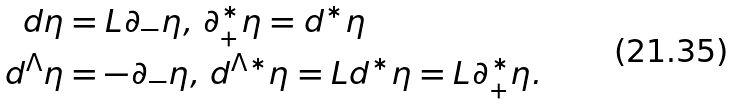<formula> <loc_0><loc_0><loc_500><loc_500>d \eta & = L \partial _ { - } \eta , \, \partial _ { + } ^ { \ast } \eta = d ^ { \ast } \eta \\ d ^ { \Lambda } \eta & = - \partial _ { - } \eta , \, d ^ { \Lambda \ast } \eta = L d ^ { \ast } \eta = L \partial _ { + } ^ { \ast } \eta .</formula> 